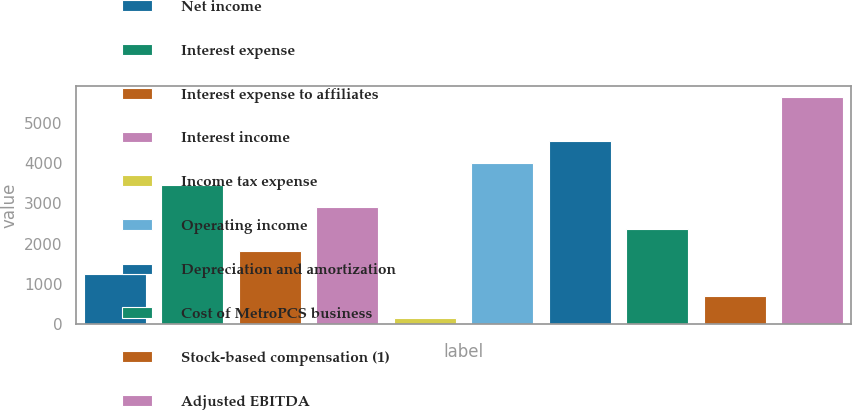Convert chart to OTSL. <chart><loc_0><loc_0><loc_500><loc_500><bar_chart><fcel>Net income<fcel>Interest expense<fcel>Interest expense to affiliates<fcel>Interest income<fcel>Income tax expense<fcel>Operating income<fcel>Depreciation and amortization<fcel>Cost of MetroPCS business<fcel>Stock-based compensation (1)<fcel>Adjusted EBITDA<nl><fcel>1260<fcel>3448<fcel>1807<fcel>2901<fcel>166<fcel>3995<fcel>4542<fcel>2354<fcel>713<fcel>5636<nl></chart> 